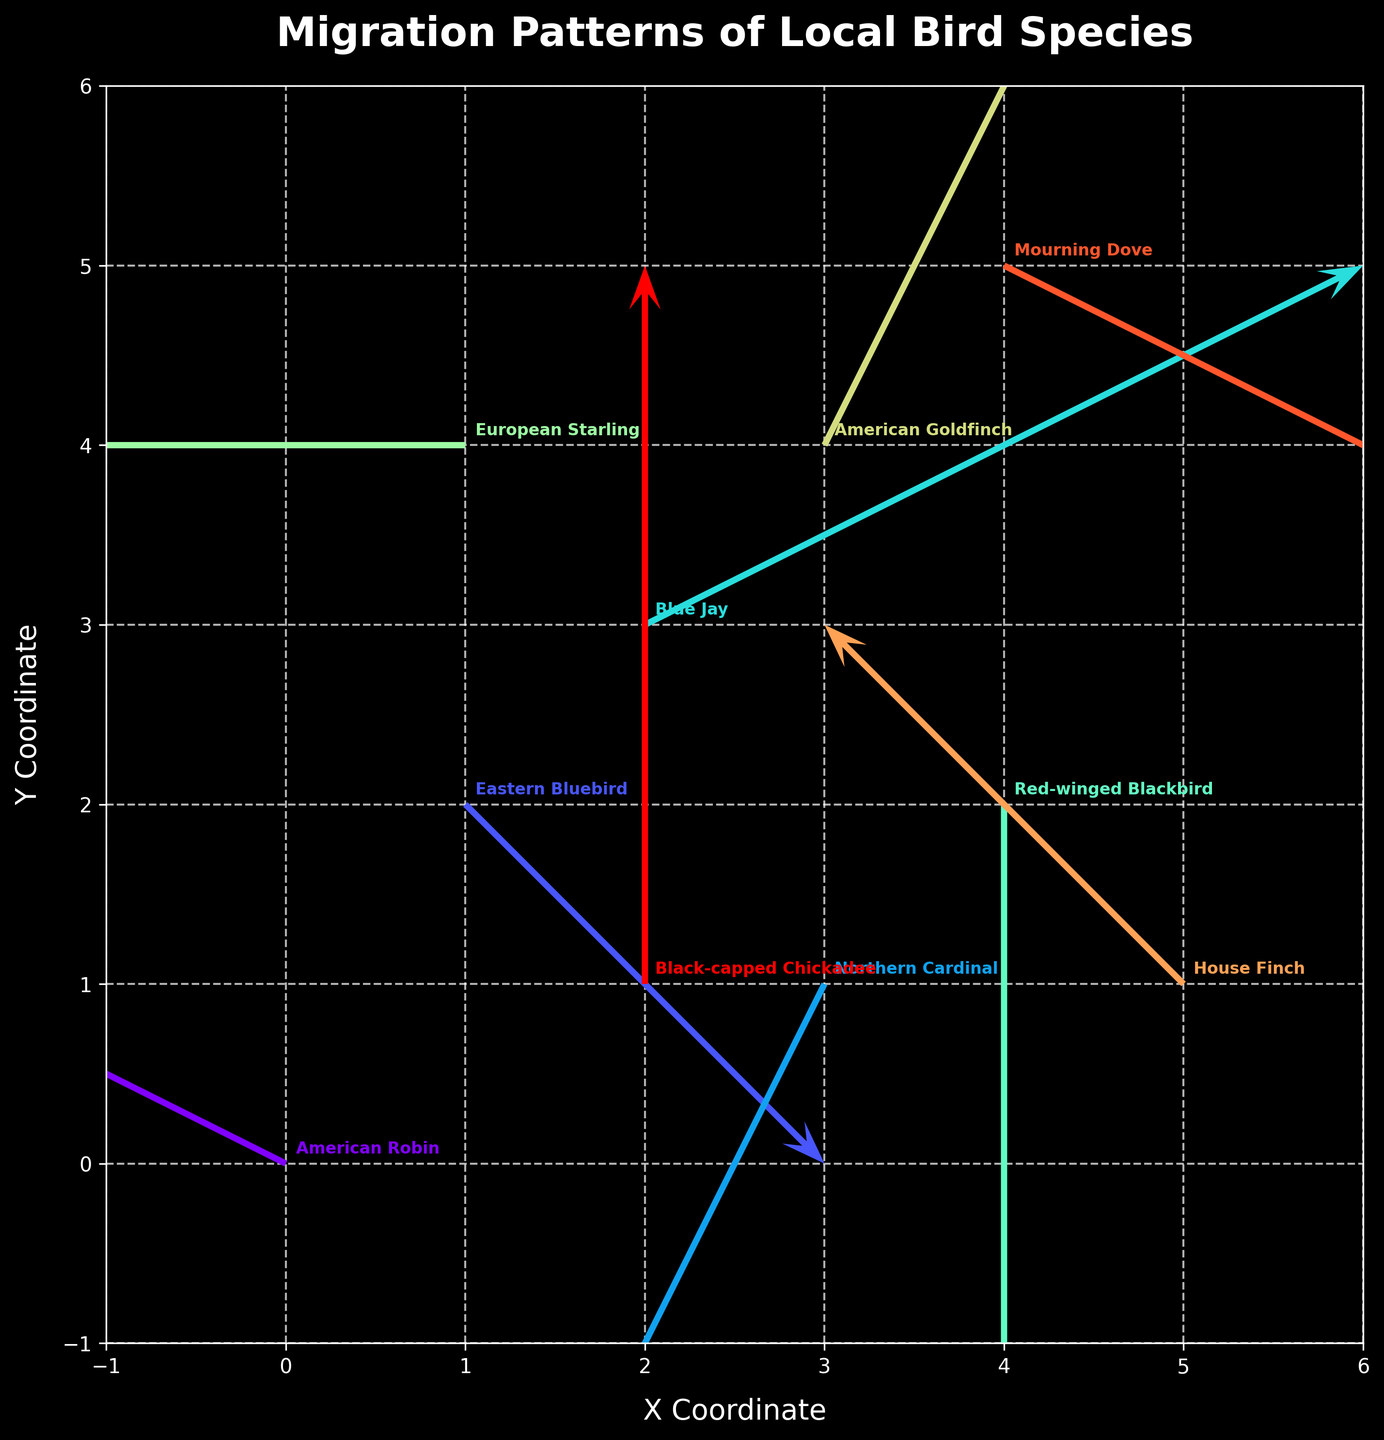which bird species moves the most to the left? The species that moves the most to the left is identified by the vector with the largest negative u-component. By examining the figure, the European Starling has a u-component of -3, the largest negative value.
Answer: European Starling which bird species has the highest upward movement? The species with the highest upward movement is determined by the largest positive v-component. Observing the plot, the Black-capped Chickadee moves upward with a v-component of 2, which is the highest positive value.
Answer: Black-capped Chickadee how many bird species experience a change in their y-coordinate by +2 units? We count the number of bird species whose vectors have a v-component of +2. In the figure, the American Goldfinch and Black-capped Chickadee both have a v-component of 2.
Answer: 2 which bird has the longest resultant vector? To find the bird with the longest resultant vector, we calculate the magnitude of each vector using the formula sqrt(u^2 + v^2). By looking at the figure, the Blue Jay with a vector (u=2, v=1) leads to a magnitude of sqrt(2^2 + 1^2) = sqrt(5), which is the largest.
Answer: Blue Jay what is the direction of movement for Northern Cardinal? The direction of movement for the Northern Cardinal is given by its vector components. The vector (u=-1, v=-2) points to the left and downwards.
Answer: left and downwards which bird species has no change in x-coordinate? The species with no change in x-coordinate have a u-component of 0. Observing the plot, the Red-winged Blackbird and Black-capped Chickadee both have a u-component of 0.
Answer: Red-winged Blackbird and Black-capped Chickadee which two species have the same initial coordinates? Birds with the same initial coordinates can be identified by looking at their (x, y) values. By closely inspecting the plot, no two species share the exact same initial coordinates.
Answer: none how many bird species migrate to a lower y-coordinate? We count the species with a negative v-component indicating a migration to a lower y-coordinate. The American Robin, Eastern Bluebird, Northern Cardinal, Red-winged Blackbird, and Mourning Dove all move downward, indicated by their negative v-components.
Answer: 5 which bird travels the shortest distance? The bird traveling the shortest distance is found by calculating the magnitude of each vector. By inspection, the Red-winged Blackbird with a vector (u=0, v=-3) has the smallest distance, sqrt(0^2 + (-3)^2) = sqrt(9) = 3.
Answer: Red-winged Blackbird 